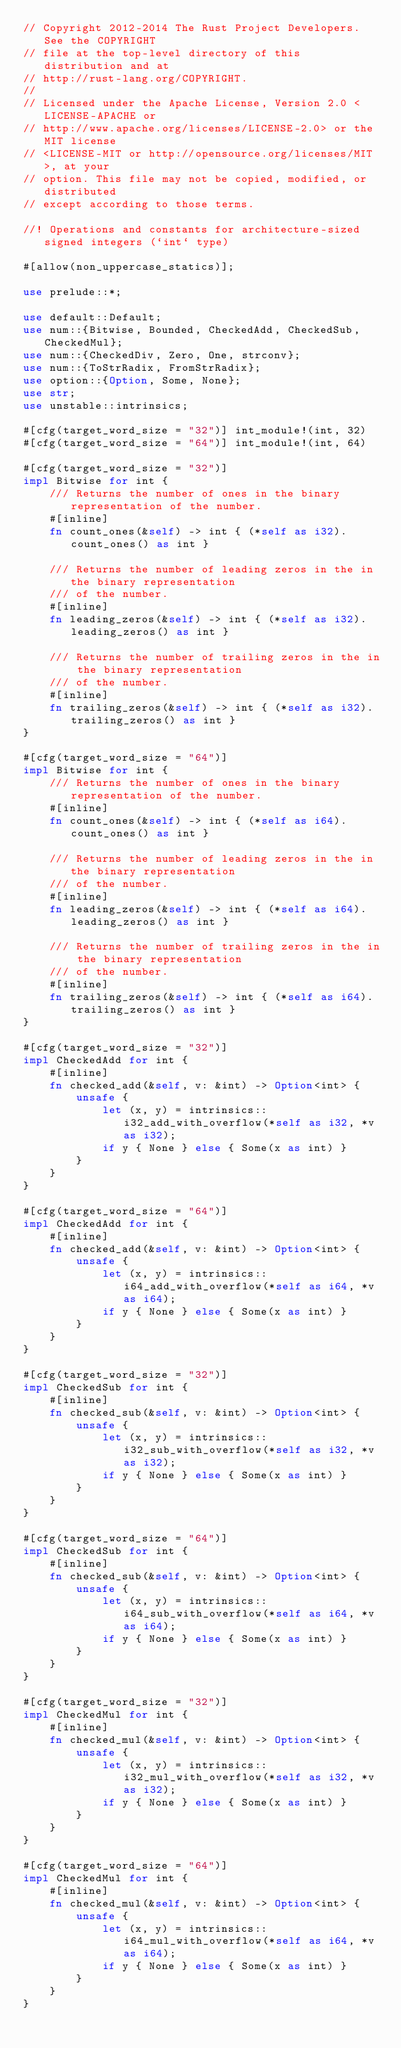<code> <loc_0><loc_0><loc_500><loc_500><_Rust_>// Copyright 2012-2014 The Rust Project Developers. See the COPYRIGHT
// file at the top-level directory of this distribution and at
// http://rust-lang.org/COPYRIGHT.
//
// Licensed under the Apache License, Version 2.0 <LICENSE-APACHE or
// http://www.apache.org/licenses/LICENSE-2.0> or the MIT license
// <LICENSE-MIT or http://opensource.org/licenses/MIT>, at your
// option. This file may not be copied, modified, or distributed
// except according to those terms.

//! Operations and constants for architecture-sized signed integers (`int` type)

#[allow(non_uppercase_statics)];

use prelude::*;

use default::Default;
use num::{Bitwise, Bounded, CheckedAdd, CheckedSub, CheckedMul};
use num::{CheckedDiv, Zero, One, strconv};
use num::{ToStrRadix, FromStrRadix};
use option::{Option, Some, None};
use str;
use unstable::intrinsics;

#[cfg(target_word_size = "32")] int_module!(int, 32)
#[cfg(target_word_size = "64")] int_module!(int, 64)

#[cfg(target_word_size = "32")]
impl Bitwise for int {
    /// Returns the number of ones in the binary representation of the number.
    #[inline]
    fn count_ones(&self) -> int { (*self as i32).count_ones() as int }

    /// Returns the number of leading zeros in the in the binary representation
    /// of the number.
    #[inline]
    fn leading_zeros(&self) -> int { (*self as i32).leading_zeros() as int }

    /// Returns the number of trailing zeros in the in the binary representation
    /// of the number.
    #[inline]
    fn trailing_zeros(&self) -> int { (*self as i32).trailing_zeros() as int }
}

#[cfg(target_word_size = "64")]
impl Bitwise for int {
    /// Returns the number of ones in the binary representation of the number.
    #[inline]
    fn count_ones(&self) -> int { (*self as i64).count_ones() as int }

    /// Returns the number of leading zeros in the in the binary representation
    /// of the number.
    #[inline]
    fn leading_zeros(&self) -> int { (*self as i64).leading_zeros() as int }

    /// Returns the number of trailing zeros in the in the binary representation
    /// of the number.
    #[inline]
    fn trailing_zeros(&self) -> int { (*self as i64).trailing_zeros() as int }
}

#[cfg(target_word_size = "32")]
impl CheckedAdd for int {
    #[inline]
    fn checked_add(&self, v: &int) -> Option<int> {
        unsafe {
            let (x, y) = intrinsics::i32_add_with_overflow(*self as i32, *v as i32);
            if y { None } else { Some(x as int) }
        }
    }
}

#[cfg(target_word_size = "64")]
impl CheckedAdd for int {
    #[inline]
    fn checked_add(&self, v: &int) -> Option<int> {
        unsafe {
            let (x, y) = intrinsics::i64_add_with_overflow(*self as i64, *v as i64);
            if y { None } else { Some(x as int) }
        }
    }
}

#[cfg(target_word_size = "32")]
impl CheckedSub for int {
    #[inline]
    fn checked_sub(&self, v: &int) -> Option<int> {
        unsafe {
            let (x, y) = intrinsics::i32_sub_with_overflow(*self as i32, *v as i32);
            if y { None } else { Some(x as int) }
        }
    }
}

#[cfg(target_word_size = "64")]
impl CheckedSub for int {
    #[inline]
    fn checked_sub(&self, v: &int) -> Option<int> {
        unsafe {
            let (x, y) = intrinsics::i64_sub_with_overflow(*self as i64, *v as i64);
            if y { None } else { Some(x as int) }
        }
    }
}

#[cfg(target_word_size = "32")]
impl CheckedMul for int {
    #[inline]
    fn checked_mul(&self, v: &int) -> Option<int> {
        unsafe {
            let (x, y) = intrinsics::i32_mul_with_overflow(*self as i32, *v as i32);
            if y { None } else { Some(x as int) }
        }
    }
}

#[cfg(target_word_size = "64")]
impl CheckedMul for int {
    #[inline]
    fn checked_mul(&self, v: &int) -> Option<int> {
        unsafe {
            let (x, y) = intrinsics::i64_mul_with_overflow(*self as i64, *v as i64);
            if y { None } else { Some(x as int) }
        }
    }
}
</code> 